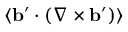<formula> <loc_0><loc_0><loc_500><loc_500>\langle { { b } ^ { \prime } \cdot ( \nabla \times { b } ^ { \prime } ) } \rangle</formula> 